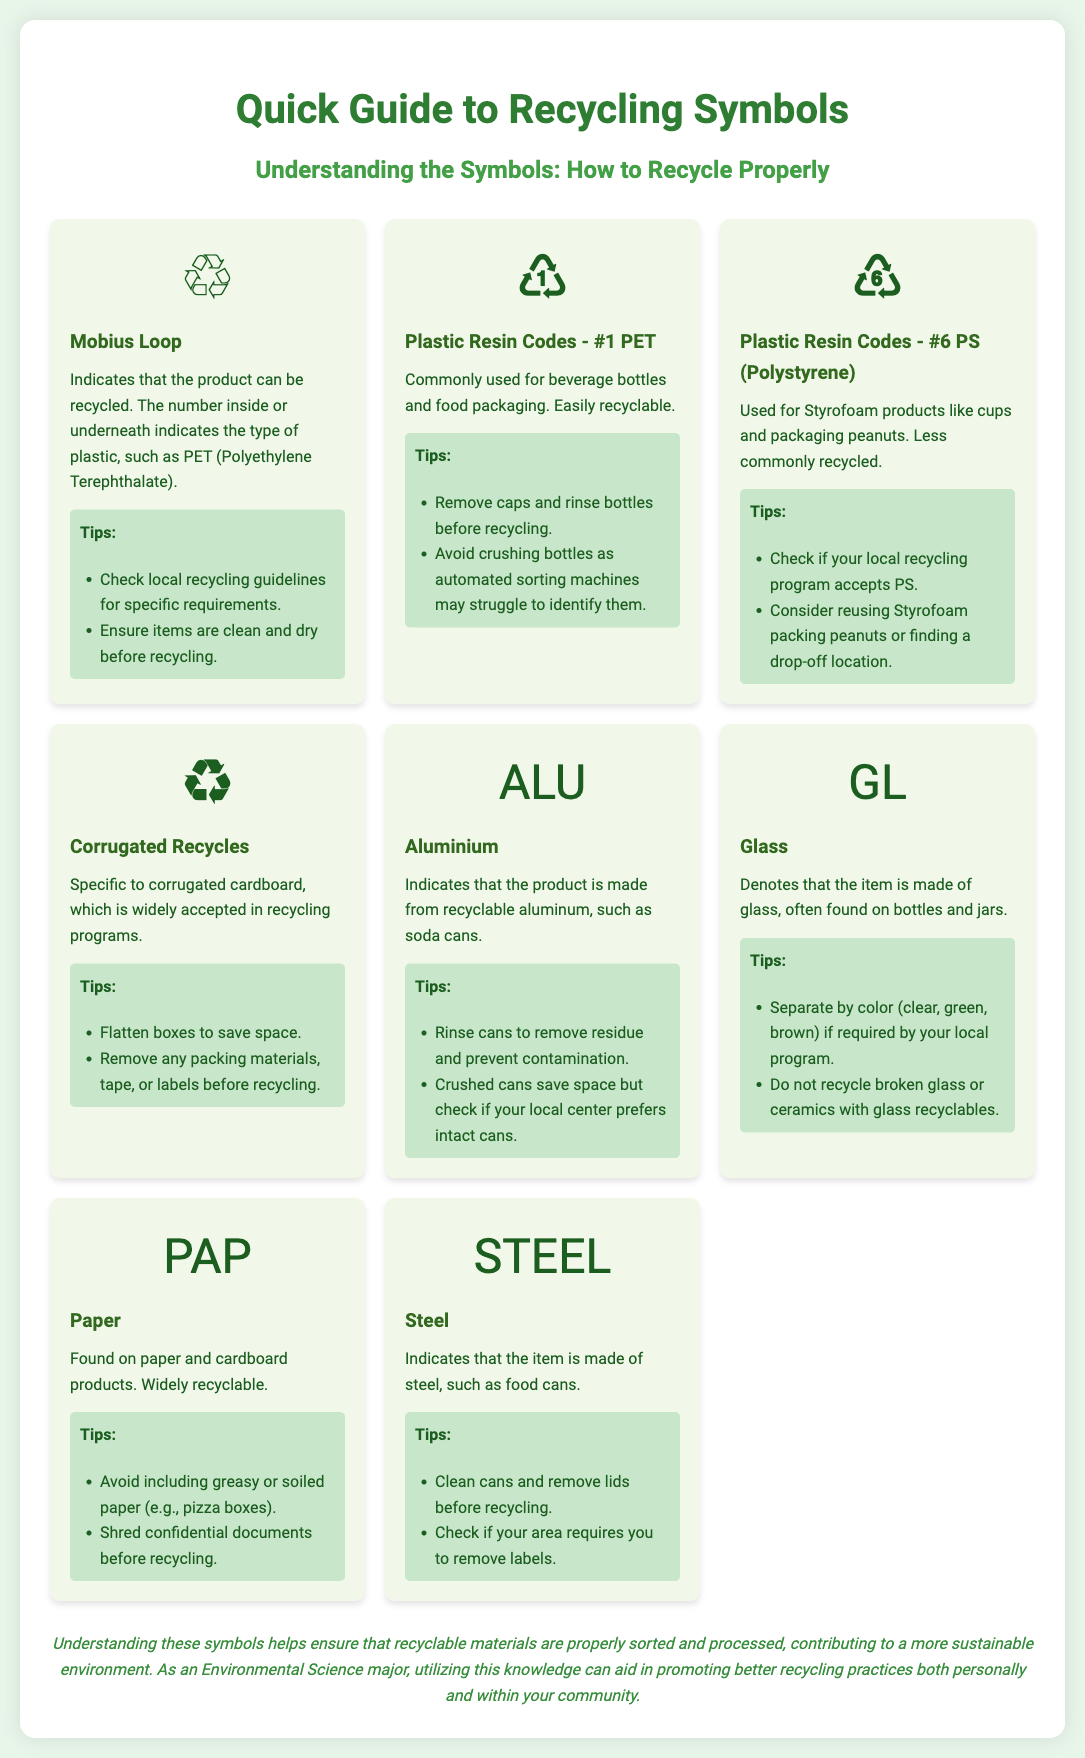What does the Mobius Loop symbol indicate? The Mobius Loop symbol indicates that the product can be recycled.
Answer: Can be recycled What items typically use the #1 PET plastic resin code? The #1 PET plastic resin code is commonly used for beverage bottles and food packaging.
Answer: Beverage bottles and food packaging Which recycling symbol is associated with polystyrene? The symbol for polystyrene is ♸.
Answer: ♸ How should corrugated cardboard be prepared for recycling? Corrugated cardboard should be flattened and any packing materials, tape, or labels removed before recycling.
Answer: Flattened, remove materials What type of container should be rinsed to prevent contamination before recycling? Aluminium containers, such as soda cans, should be rinsed.
Answer: Aluminium containers Which recycling symbol represents paper products? The symbol that represents paper products is PAP.
Answer: PAP What color separation might be required for glass recycling? Glass recycling might require separation by color: clear, green, brown.
Answer: By color How should food cans made of steel be prepared for recycling? Steel food cans should be cleaned and lids removed before recycling.
Answer: Cleaned, remove lids Which recycling material is noted for being less commonly recycled? The material noted for being less commonly recycled is Styrofoam.
Answer: Styrofoam 